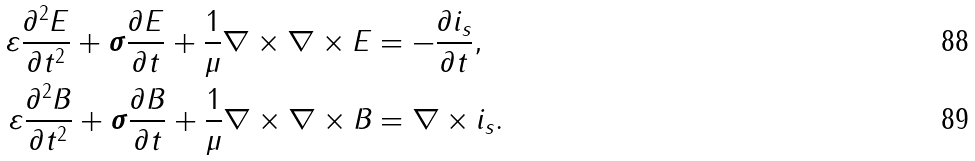Convert formula to latex. <formula><loc_0><loc_0><loc_500><loc_500>\varepsilon \frac { \partial ^ { 2 } E } { \partial t ^ { 2 } } + \boldsymbol \sigma \frac { \partial E } { \partial t } + \frac { 1 } { \mu } \nabla \times \nabla \times E & = - \frac { \partial i _ { s } } { \partial t } , \\ \varepsilon \frac { \partial ^ { 2 } B } { \partial t ^ { 2 } } + \boldsymbol \sigma \frac { \partial B } { \partial t } + \frac { 1 } { \mu } \nabla \times \nabla \times B & = \nabla \times i _ { s } .</formula> 